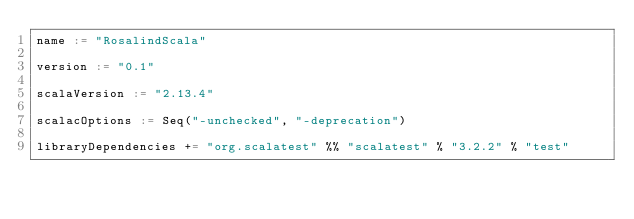Convert code to text. <code><loc_0><loc_0><loc_500><loc_500><_Scala_>name := "RosalindScala"

version := "0.1"

scalaVersion := "2.13.4"

scalacOptions := Seq("-unchecked", "-deprecation")

libraryDependencies += "org.scalatest" %% "scalatest" % "3.2.2" % "test"
</code> 